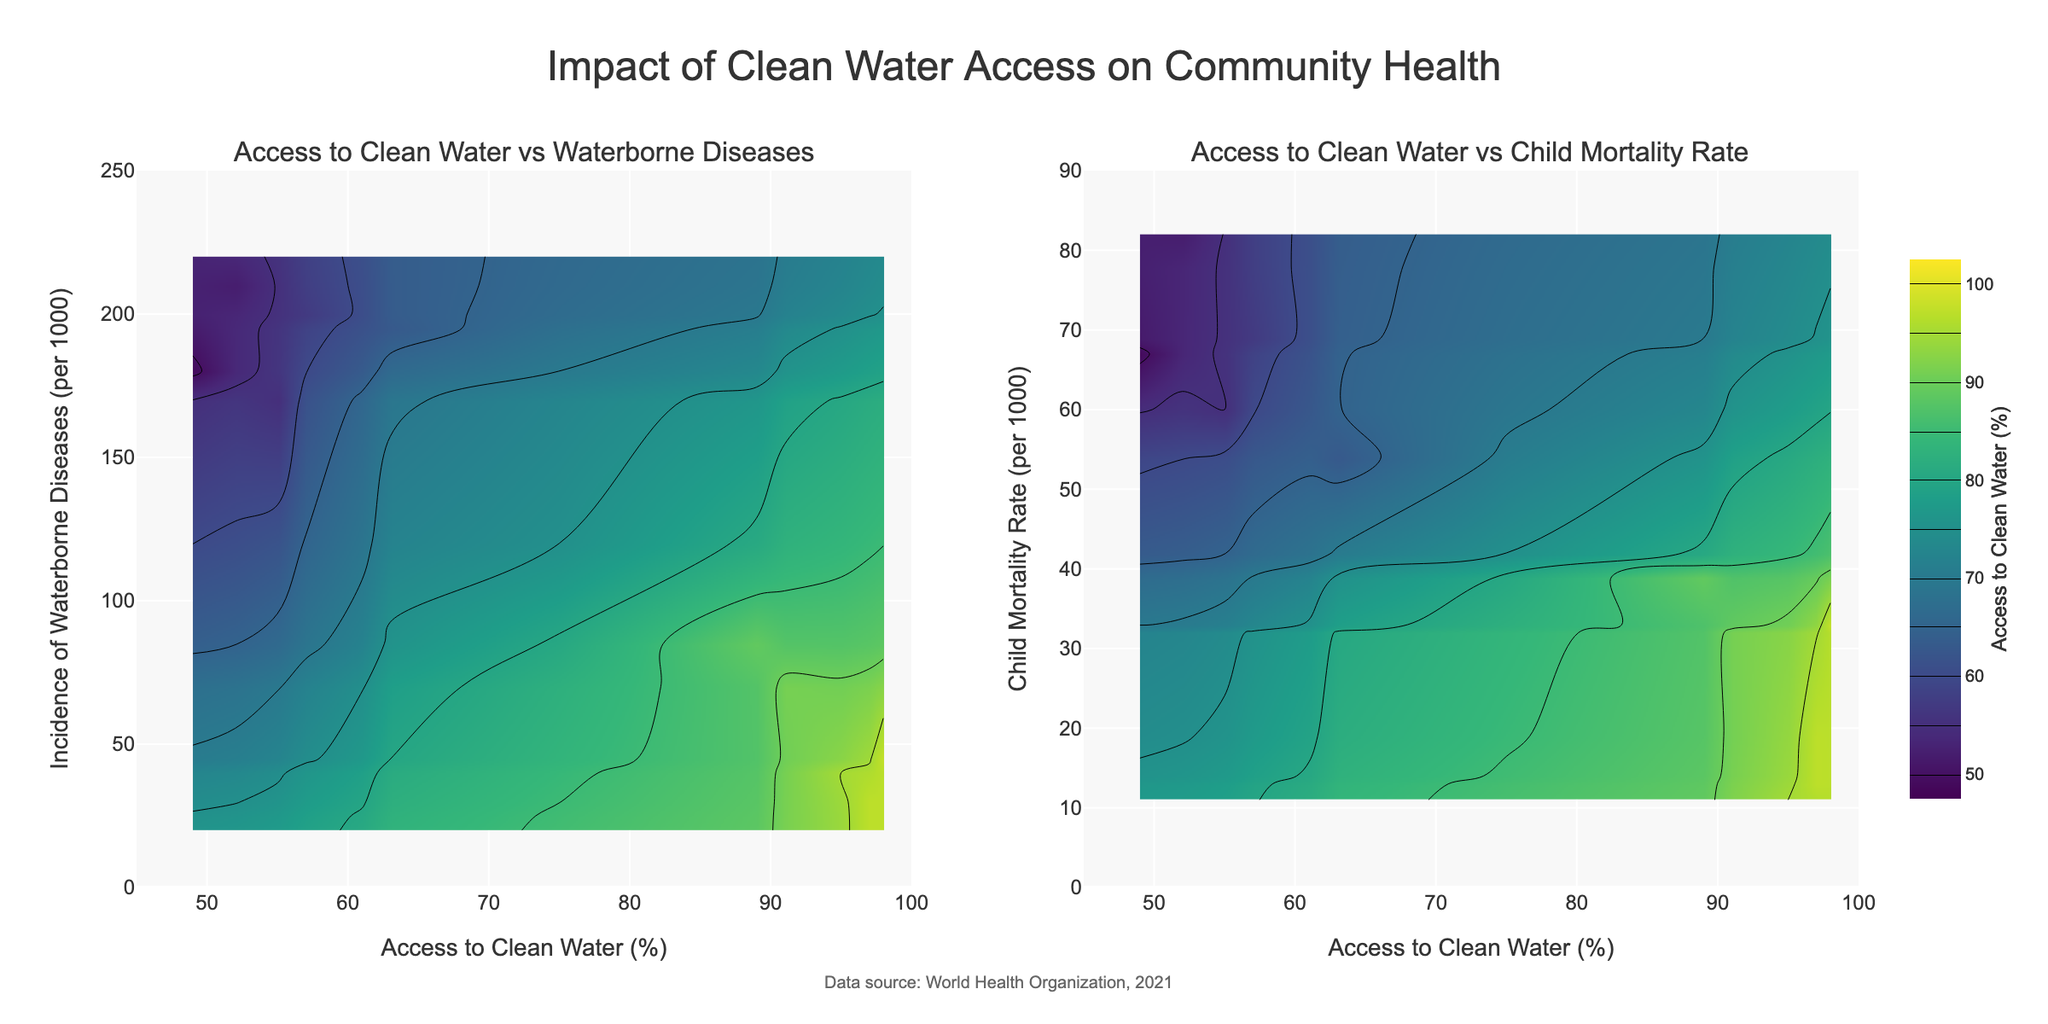How many subplots are there in the figure? There are two subplots titled "Access to Clean Water vs Waterborne Diseases" and "Access to Clean Water vs Child Mortality Rate".
Answer: 2 What is the title of the figure? The title is displayed at the top of the figure. It reads "Impact of Clean Water Access on Community Health".
Answer: "Impact of Clean Water Access on Community Health" Which region has the highest access to clean water according to the figure? The hover information shows the access percentage for different countries. Egypt, Brazil, and Mexico have the highest access to clean water at 97%.
Answer: Egypt, Brazil, Mexico What is the relationship between access to clean water and the incidence of waterborne diseases for Sub-Saharan Africa? By examining the left subplot, it can be observed that as the access to clean water percentage increases, the incidence of waterborne diseases decreases for the countries in Sub-Saharan Africa like Nigeria, Ethiopia, and Kenya.
Answer: Negative correlation Which country has the lowest child mortality rate and what is its access to clean water percentage? By inspecting the hover information on the right subplot, it can be seen that Thailand has the lowest child mortality rate of 11 per 1000 and an access to clean water percentage of 95%.
Answer: Thailand, 95% What is the range of "Access to Clean Water (%)" in the figure? The x-axes of both subplots have an identical range, which is specified from 45% to 100%.
Answer: 45% to 100% How does the access to clean water in Haiti compare with the child mortality rate in Cambodia? By examining the right subplot, Haiti has an access to clean water percentage of 57% with a child mortality rate of 69 per 1000, while Cambodia has an access to clean water of 75% with a child mortality rate of 42 per 1000. Cambodia has a higher access to clean water percentage and a lower child mortality rate compared to Haiti.
Answer: Cambodia higher, lower Which data point has the highest incidence of waterborne diseases, and what is the corresponding access to clean water percentage? By observing the left subplot, the highest incidence of waterborne diseases is 220 per 1000 in Nigeria, where the access to clean water percentage is 61%.
Answer: Nigeria, 61% What pattern can be observed in child mortality rates as access to clean water increases? Reviewing the right subplot, there is a general downward trend, indicating that higher access to clean water is associated with lower child mortality rates.
Answer: Decreasing Between India and Afghanistan, which country has a lower incidence of waterborne diseases, and what are their respective values? By comparing the hover information on the left subplot, India has an incidence of waterborne diseases of 85 per 1000, while Afghanistan has 170 per 1000. Therefore, India has a lower incidence.
Answer: India, 85 per 1000 